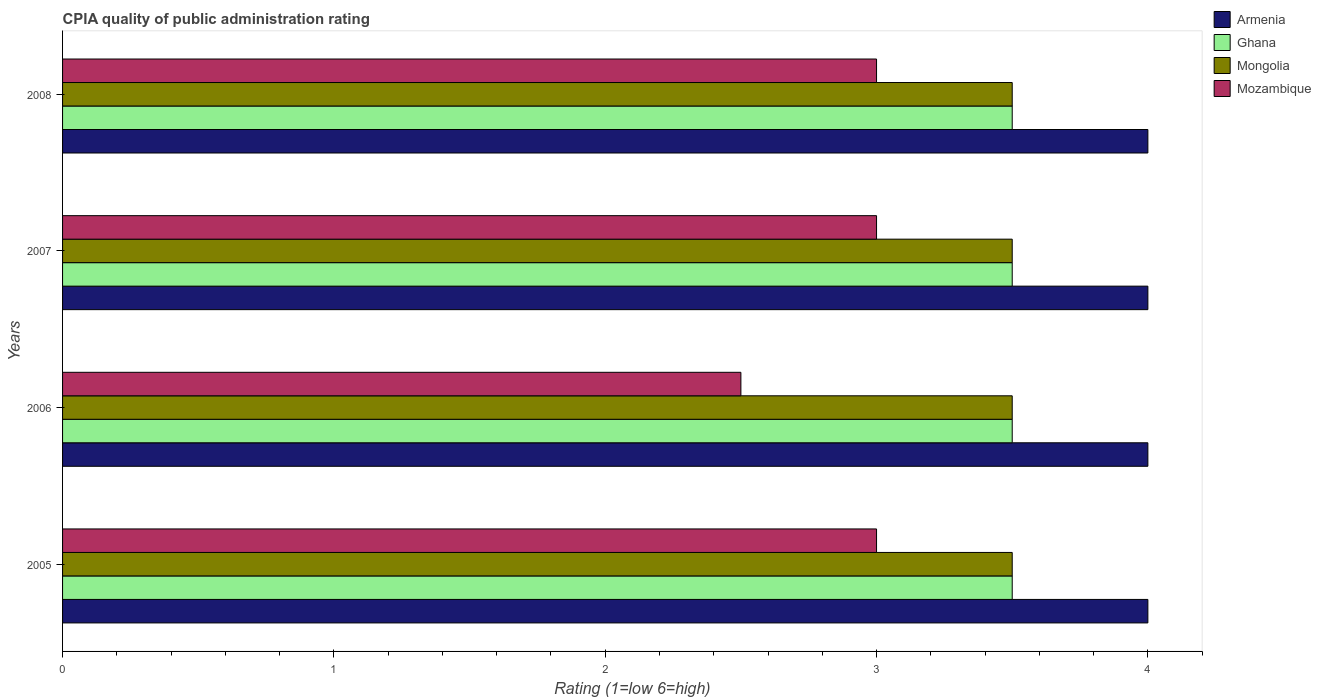How many groups of bars are there?
Make the answer very short. 4. Are the number of bars on each tick of the Y-axis equal?
Provide a short and direct response. Yes. How many bars are there on the 2nd tick from the top?
Your answer should be very brief. 4. What is the CPIA rating in Mozambique in 2007?
Your answer should be very brief. 3. Across all years, what is the maximum CPIA rating in Ghana?
Provide a succinct answer. 3.5. Across all years, what is the minimum CPIA rating in Armenia?
Give a very brief answer. 4. In which year was the CPIA rating in Mongolia minimum?
Provide a succinct answer. 2005. What is the total CPIA rating in Mongolia in the graph?
Keep it short and to the point. 14. What is the difference between the CPIA rating in Mozambique in 2005 and that in 2006?
Provide a short and direct response. 0.5. What is the difference between the CPIA rating in Mongolia in 2005 and the CPIA rating in Ghana in 2007?
Your response must be concise. 0. What is the average CPIA rating in Mozambique per year?
Provide a succinct answer. 2.88. What is the difference between the highest and the lowest CPIA rating in Armenia?
Offer a terse response. 0. In how many years, is the CPIA rating in Mozambique greater than the average CPIA rating in Mozambique taken over all years?
Your response must be concise. 3. Is the sum of the CPIA rating in Armenia in 2005 and 2007 greater than the maximum CPIA rating in Mongolia across all years?
Ensure brevity in your answer.  Yes. Is it the case that in every year, the sum of the CPIA rating in Ghana and CPIA rating in Mongolia is greater than the sum of CPIA rating in Armenia and CPIA rating in Mozambique?
Keep it short and to the point. No. What does the 4th bar from the top in 2006 represents?
Make the answer very short. Armenia. What does the 3rd bar from the bottom in 2008 represents?
Your answer should be very brief. Mongolia. Is it the case that in every year, the sum of the CPIA rating in Mongolia and CPIA rating in Armenia is greater than the CPIA rating in Ghana?
Offer a very short reply. Yes. Are all the bars in the graph horizontal?
Provide a succinct answer. Yes. How many years are there in the graph?
Make the answer very short. 4. What is the difference between two consecutive major ticks on the X-axis?
Ensure brevity in your answer.  1. Does the graph contain any zero values?
Provide a short and direct response. No. Where does the legend appear in the graph?
Provide a short and direct response. Top right. What is the title of the graph?
Make the answer very short. CPIA quality of public administration rating. What is the label or title of the X-axis?
Offer a terse response. Rating (1=low 6=high). What is the Rating (1=low 6=high) of Armenia in 2005?
Ensure brevity in your answer.  4. What is the Rating (1=low 6=high) in Mongolia in 2005?
Provide a succinct answer. 3.5. What is the Rating (1=low 6=high) in Armenia in 2006?
Offer a terse response. 4. What is the Rating (1=low 6=high) of Ghana in 2006?
Offer a terse response. 3.5. What is the Rating (1=low 6=high) of Mongolia in 2006?
Offer a very short reply. 3.5. What is the Rating (1=low 6=high) in Mozambique in 2006?
Keep it short and to the point. 2.5. What is the Rating (1=low 6=high) in Ghana in 2007?
Ensure brevity in your answer.  3.5. What is the Rating (1=low 6=high) in Mongolia in 2007?
Your answer should be compact. 3.5. What is the Rating (1=low 6=high) in Mozambique in 2007?
Provide a succinct answer. 3. What is the Rating (1=low 6=high) of Armenia in 2008?
Offer a terse response. 4. What is the Rating (1=low 6=high) of Ghana in 2008?
Your answer should be compact. 3.5. What is the Rating (1=low 6=high) in Mongolia in 2008?
Your response must be concise. 3.5. What is the Rating (1=low 6=high) of Mozambique in 2008?
Provide a succinct answer. 3. Across all years, what is the maximum Rating (1=low 6=high) of Ghana?
Provide a succinct answer. 3.5. Across all years, what is the maximum Rating (1=low 6=high) in Mozambique?
Keep it short and to the point. 3. Across all years, what is the minimum Rating (1=low 6=high) in Ghana?
Offer a very short reply. 3.5. Across all years, what is the minimum Rating (1=low 6=high) in Mongolia?
Ensure brevity in your answer.  3.5. What is the total Rating (1=low 6=high) of Armenia in the graph?
Your answer should be compact. 16. What is the difference between the Rating (1=low 6=high) in Armenia in 2005 and that in 2007?
Keep it short and to the point. 0. What is the difference between the Rating (1=low 6=high) in Mongolia in 2005 and that in 2008?
Your response must be concise. 0. What is the difference between the Rating (1=low 6=high) of Mozambique in 2005 and that in 2008?
Make the answer very short. 0. What is the difference between the Rating (1=low 6=high) in Ghana in 2006 and that in 2007?
Provide a succinct answer. 0. What is the difference between the Rating (1=low 6=high) of Armenia in 2006 and that in 2008?
Offer a very short reply. 0. What is the difference between the Rating (1=low 6=high) in Mongolia in 2006 and that in 2008?
Provide a short and direct response. 0. What is the difference between the Rating (1=low 6=high) in Ghana in 2007 and that in 2008?
Your response must be concise. 0. What is the difference between the Rating (1=low 6=high) of Mongolia in 2007 and that in 2008?
Provide a succinct answer. 0. What is the difference between the Rating (1=low 6=high) of Armenia in 2005 and the Rating (1=low 6=high) of Ghana in 2006?
Your response must be concise. 0.5. What is the difference between the Rating (1=low 6=high) in Armenia in 2005 and the Rating (1=low 6=high) in Mongolia in 2006?
Ensure brevity in your answer.  0.5. What is the difference between the Rating (1=low 6=high) in Armenia in 2005 and the Rating (1=low 6=high) in Mozambique in 2006?
Offer a very short reply. 1.5. What is the difference between the Rating (1=low 6=high) of Ghana in 2005 and the Rating (1=low 6=high) of Mozambique in 2006?
Offer a terse response. 1. What is the difference between the Rating (1=low 6=high) in Mongolia in 2005 and the Rating (1=low 6=high) in Mozambique in 2006?
Your response must be concise. 1. What is the difference between the Rating (1=low 6=high) in Armenia in 2005 and the Rating (1=low 6=high) in Mongolia in 2007?
Provide a short and direct response. 0.5. What is the difference between the Rating (1=low 6=high) of Armenia in 2005 and the Rating (1=low 6=high) of Mozambique in 2007?
Your answer should be compact. 1. What is the difference between the Rating (1=low 6=high) of Ghana in 2005 and the Rating (1=low 6=high) of Mozambique in 2007?
Your response must be concise. 0.5. What is the difference between the Rating (1=low 6=high) in Mongolia in 2005 and the Rating (1=low 6=high) in Mozambique in 2007?
Your answer should be very brief. 0.5. What is the difference between the Rating (1=low 6=high) of Armenia in 2005 and the Rating (1=low 6=high) of Ghana in 2008?
Your response must be concise. 0.5. What is the difference between the Rating (1=low 6=high) of Armenia in 2005 and the Rating (1=low 6=high) of Mozambique in 2008?
Keep it short and to the point. 1. What is the difference between the Rating (1=low 6=high) in Mongolia in 2005 and the Rating (1=low 6=high) in Mozambique in 2008?
Your response must be concise. 0.5. What is the difference between the Rating (1=low 6=high) in Armenia in 2006 and the Rating (1=low 6=high) in Mongolia in 2007?
Keep it short and to the point. 0.5. What is the difference between the Rating (1=low 6=high) in Armenia in 2006 and the Rating (1=low 6=high) in Mozambique in 2007?
Ensure brevity in your answer.  1. What is the difference between the Rating (1=low 6=high) of Mongolia in 2006 and the Rating (1=low 6=high) of Mozambique in 2007?
Make the answer very short. 0.5. What is the difference between the Rating (1=low 6=high) in Armenia in 2006 and the Rating (1=low 6=high) in Ghana in 2008?
Provide a short and direct response. 0.5. What is the difference between the Rating (1=low 6=high) of Ghana in 2006 and the Rating (1=low 6=high) of Mozambique in 2008?
Keep it short and to the point. 0.5. What is the difference between the Rating (1=low 6=high) of Armenia in 2007 and the Rating (1=low 6=high) of Ghana in 2008?
Your answer should be very brief. 0.5. What is the difference between the Rating (1=low 6=high) of Ghana in 2007 and the Rating (1=low 6=high) of Mongolia in 2008?
Give a very brief answer. 0. What is the difference between the Rating (1=low 6=high) of Ghana in 2007 and the Rating (1=low 6=high) of Mozambique in 2008?
Give a very brief answer. 0.5. What is the difference between the Rating (1=low 6=high) of Mongolia in 2007 and the Rating (1=low 6=high) of Mozambique in 2008?
Make the answer very short. 0.5. What is the average Rating (1=low 6=high) of Armenia per year?
Your response must be concise. 4. What is the average Rating (1=low 6=high) of Mongolia per year?
Ensure brevity in your answer.  3.5. What is the average Rating (1=low 6=high) of Mozambique per year?
Ensure brevity in your answer.  2.88. In the year 2005, what is the difference between the Rating (1=low 6=high) of Armenia and Rating (1=low 6=high) of Ghana?
Ensure brevity in your answer.  0.5. In the year 2005, what is the difference between the Rating (1=low 6=high) in Mongolia and Rating (1=low 6=high) in Mozambique?
Give a very brief answer. 0.5. In the year 2006, what is the difference between the Rating (1=low 6=high) of Armenia and Rating (1=low 6=high) of Mongolia?
Ensure brevity in your answer.  0.5. In the year 2006, what is the difference between the Rating (1=low 6=high) of Ghana and Rating (1=low 6=high) of Mozambique?
Your answer should be very brief. 1. In the year 2006, what is the difference between the Rating (1=low 6=high) in Mongolia and Rating (1=low 6=high) in Mozambique?
Ensure brevity in your answer.  1. In the year 2007, what is the difference between the Rating (1=low 6=high) of Armenia and Rating (1=low 6=high) of Ghana?
Provide a short and direct response. 0.5. In the year 2007, what is the difference between the Rating (1=low 6=high) in Armenia and Rating (1=low 6=high) in Mongolia?
Offer a terse response. 0.5. In the year 2007, what is the difference between the Rating (1=low 6=high) in Ghana and Rating (1=low 6=high) in Mozambique?
Your answer should be compact. 0.5. In the year 2007, what is the difference between the Rating (1=low 6=high) in Mongolia and Rating (1=low 6=high) in Mozambique?
Keep it short and to the point. 0.5. In the year 2008, what is the difference between the Rating (1=low 6=high) in Armenia and Rating (1=low 6=high) in Ghana?
Make the answer very short. 0.5. In the year 2008, what is the difference between the Rating (1=low 6=high) in Mongolia and Rating (1=low 6=high) in Mozambique?
Offer a very short reply. 0.5. What is the ratio of the Rating (1=low 6=high) in Armenia in 2005 to that in 2006?
Your answer should be very brief. 1. What is the ratio of the Rating (1=low 6=high) of Ghana in 2005 to that in 2006?
Your answer should be compact. 1. What is the ratio of the Rating (1=low 6=high) of Mongolia in 2005 to that in 2006?
Your answer should be very brief. 1. What is the ratio of the Rating (1=low 6=high) in Mozambique in 2005 to that in 2006?
Your answer should be very brief. 1.2. What is the ratio of the Rating (1=low 6=high) in Ghana in 2005 to that in 2007?
Provide a short and direct response. 1. What is the ratio of the Rating (1=low 6=high) in Armenia in 2005 to that in 2008?
Provide a short and direct response. 1. What is the ratio of the Rating (1=low 6=high) in Mozambique in 2005 to that in 2008?
Keep it short and to the point. 1. What is the ratio of the Rating (1=low 6=high) of Armenia in 2006 to that in 2007?
Provide a succinct answer. 1. What is the ratio of the Rating (1=low 6=high) in Ghana in 2006 to that in 2007?
Provide a short and direct response. 1. What is the ratio of the Rating (1=low 6=high) of Mozambique in 2006 to that in 2007?
Ensure brevity in your answer.  0.83. What is the ratio of the Rating (1=low 6=high) in Mozambique in 2006 to that in 2008?
Your response must be concise. 0.83. What is the difference between the highest and the second highest Rating (1=low 6=high) of Armenia?
Ensure brevity in your answer.  0. What is the difference between the highest and the second highest Rating (1=low 6=high) in Ghana?
Offer a terse response. 0. What is the difference between the highest and the second highest Rating (1=low 6=high) of Mongolia?
Your response must be concise. 0. What is the difference between the highest and the second highest Rating (1=low 6=high) in Mozambique?
Provide a short and direct response. 0. What is the difference between the highest and the lowest Rating (1=low 6=high) in Ghana?
Ensure brevity in your answer.  0. What is the difference between the highest and the lowest Rating (1=low 6=high) of Mongolia?
Your answer should be very brief. 0. 